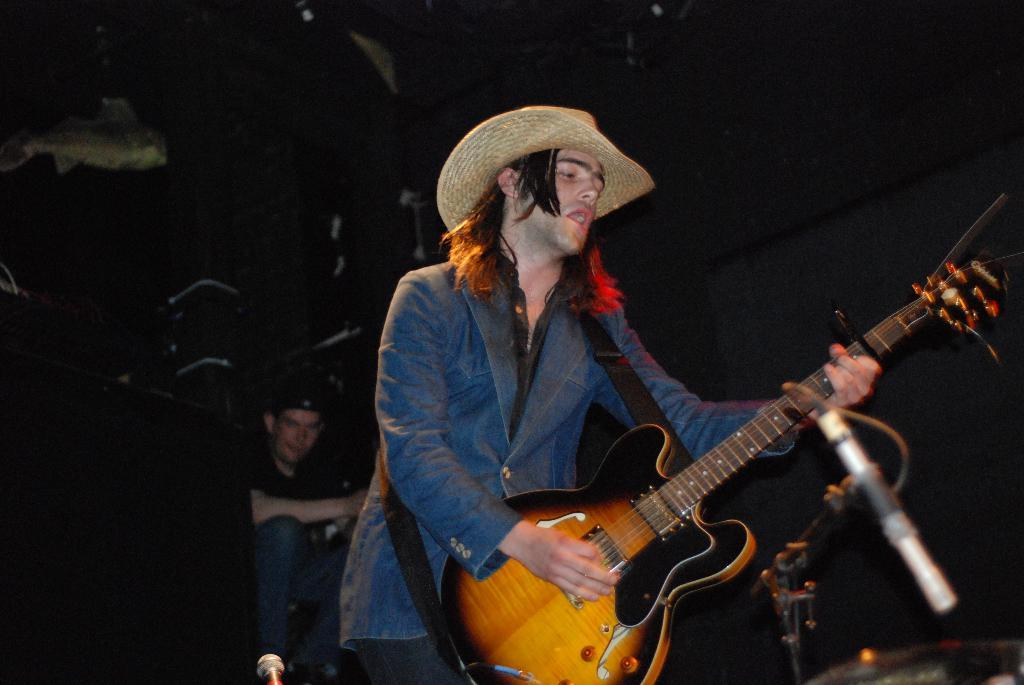What is the man in the image doing? The man is playing the guitar. What object is the man holding in the image? The man is holding a guitar. Can you describe the person in the background of the image? Unfortunately, the provided facts do not give any information about the person in the background. What type of cord is being used to connect the guitar to the amplifier in the image? There is no amplifier or cord present in the image; the man is simply playing the guitar. 